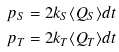<formula> <loc_0><loc_0><loc_500><loc_500>p _ { S } & = 2 k _ { S } \langle Q _ { S } \rangle d t \\ p _ { T } & = 2 k _ { T } \langle Q _ { T } \rangle d t</formula> 